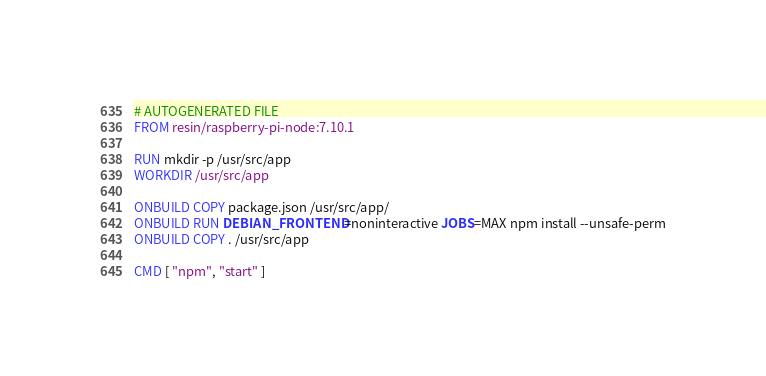Convert code to text. <code><loc_0><loc_0><loc_500><loc_500><_Dockerfile_># AUTOGENERATED FILE
FROM resin/raspberry-pi-node:7.10.1

RUN mkdir -p /usr/src/app
WORKDIR /usr/src/app

ONBUILD COPY package.json /usr/src/app/
ONBUILD RUN DEBIAN_FRONTEND=noninteractive JOBS=MAX npm install --unsafe-perm
ONBUILD COPY . /usr/src/app

CMD [ "npm", "start" ]
</code> 